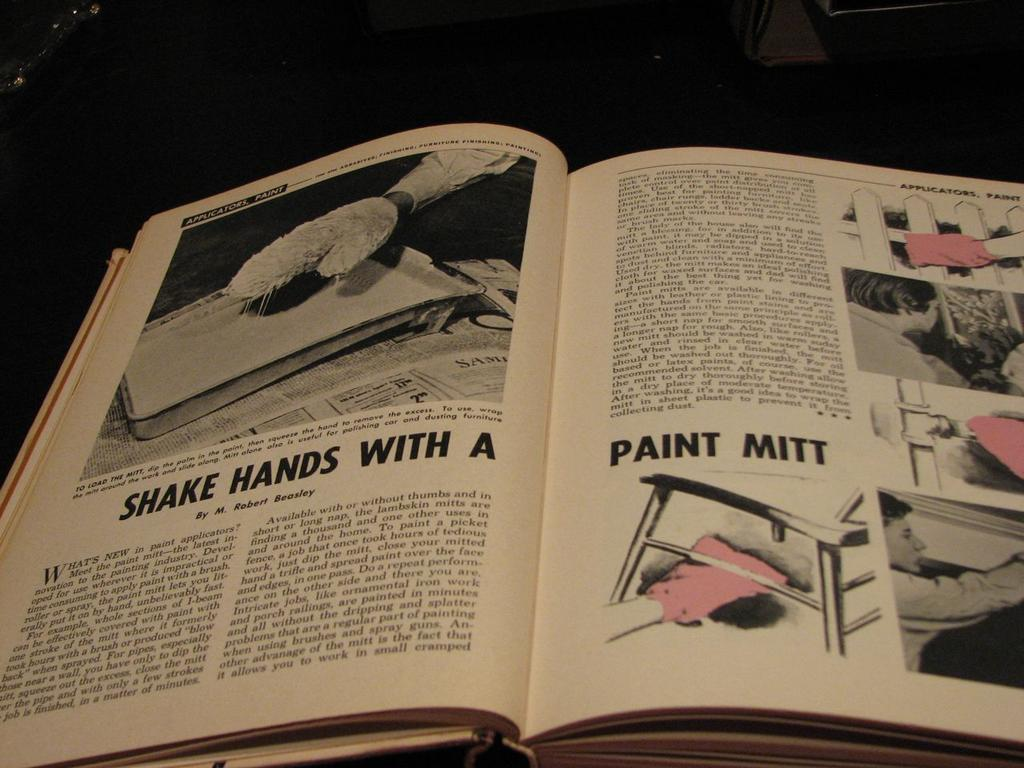<image>
Write a terse but informative summary of the picture. A collection of cards on a table includes one that reads "Make a Haiku." 